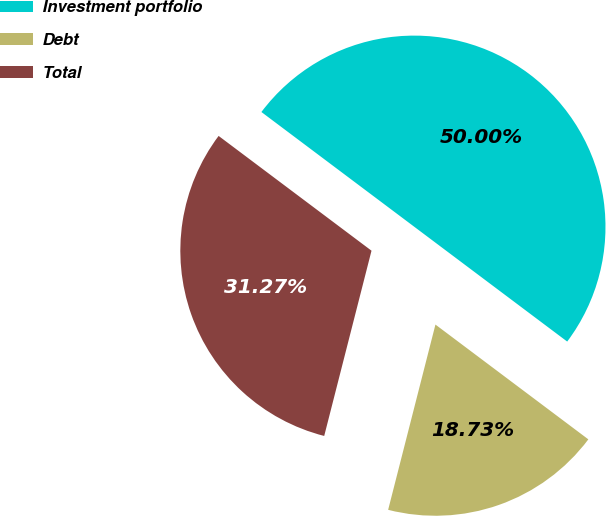<chart> <loc_0><loc_0><loc_500><loc_500><pie_chart><fcel>Investment portfolio<fcel>Debt<fcel>Total<nl><fcel>50.0%<fcel>18.73%<fcel>31.27%<nl></chart> 